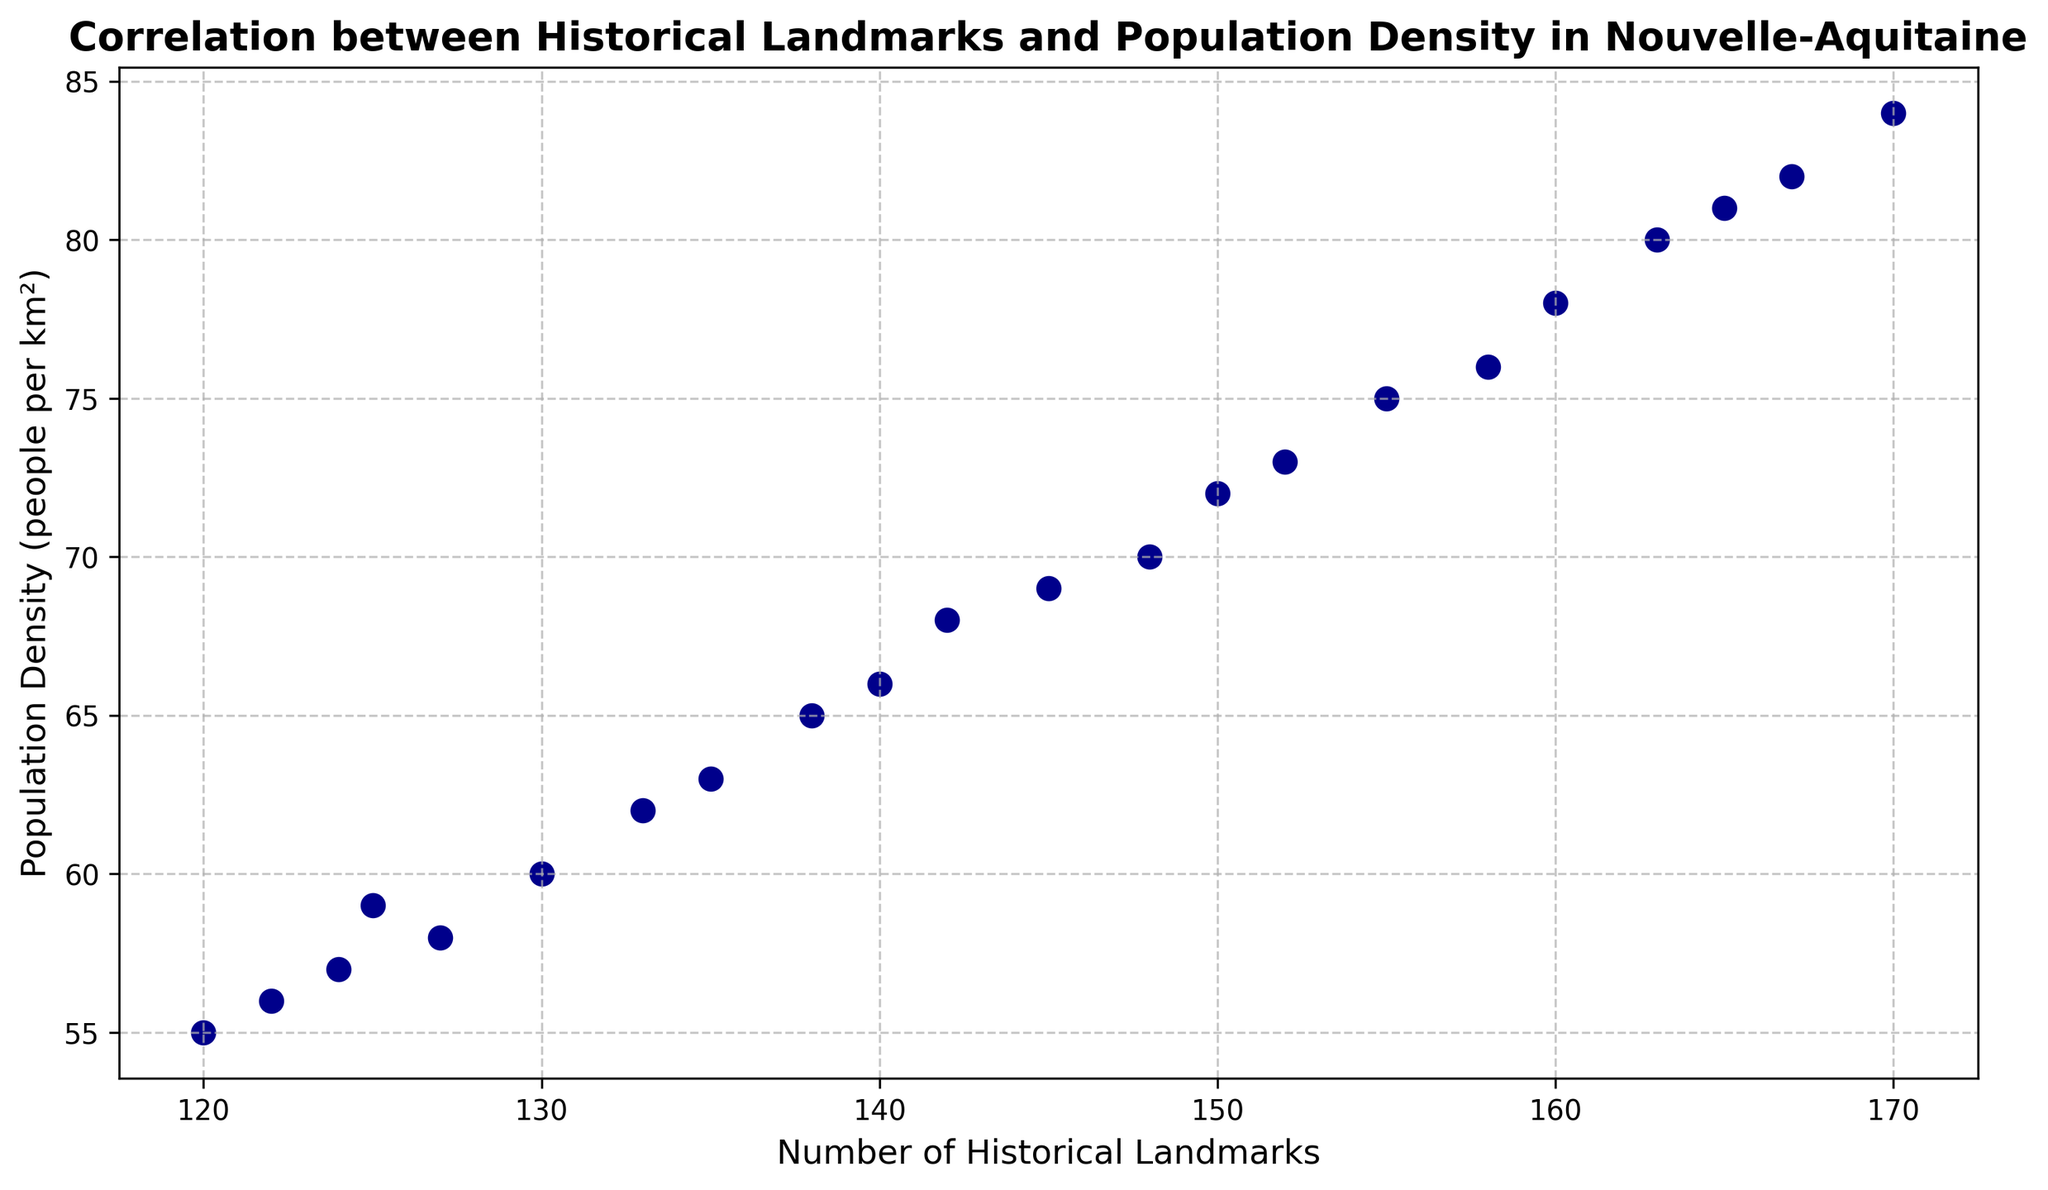What is the trend in population density as the number of historical landmarks increases? Observing the scatter plot, it is clear that as the number of historical landmarks increases, the population density also increases.
Answer: Increasing Which year corresponds to the highest number of historical landmarks and what is the population density for that year? The year 2021 corresponds to the highest number of historical landmarks (170) and the population density for that year is 84 people per km².
Answer: 2021; 84 How many historical landmarks were there in 2010 and what was the population density that year? Referring to the scatter plot, in 2010, there were 142 historical landmarks, and the population density was 68 people per km².
Answer: 142; 68 Is the population density more than 70 people per km² when the number of historical landmarks is greater than 150? When the number of historical landmarks is greater than 150, the population density ranges from 75 to 84 people per km², which is indeed more than 70 people per km².
Answer: Yes What can be inferred about the correlation between the number of historical landmarks and population density? The scatter plot shows a positive correlation, indicating that as the number of historical landmarks increases, the population density also tends to increase.
Answer: Positive Correlation Calculate the average population density for the years when historical landmarks were between 150 and 160 (inclusive)? For years with 150 to 160 historical landmarks (2013 to 2017), the population densities are 72, 73, 75, 76, and 78. The average is calculated as (72 + 73 + 75 + 76 + 78)/5 = 74.8.
Answer: 74.8 Which year showed the largest increase in the number of historical landmarks compared to the previous year, and what was the corresponding change in population density? Between 2011 and 2012, the number of historical landmarks increased by 3 (145 to 148), and the population density increased by 1 (69 to 70). This can be quickly checked iteratively.
Answer: 2011-2012; 1 What is the overall range of population densities plotted on the scatter plot? The minimum population density is 55 people per km² (year 2000) and the maximum is 84 people per km² (year 2021), resulting in a range of 84 - 55 = 29.
Answer: 29 Compare the rate of increase of historical landmarks and population density between 2017 and 2021. From 2017 (160 landmarks, 78 density) to 2021 (170 landmarks, 84 density), the increase in landmarks is 10 (170 - 160) and the increase in density is 6 (84 - 78), yearly increment can also be compared.
Answer: Landmarks: 10; Density: 6 How many times did the population density decrease or stay the same despite an increase in the number of historical landmarks? Referring to the scatter plot, the population density decreased from 59 to 58 in 2004 while the number of landmarks increased from 125 to 127. This is the only instance.
Answer: 1 time 